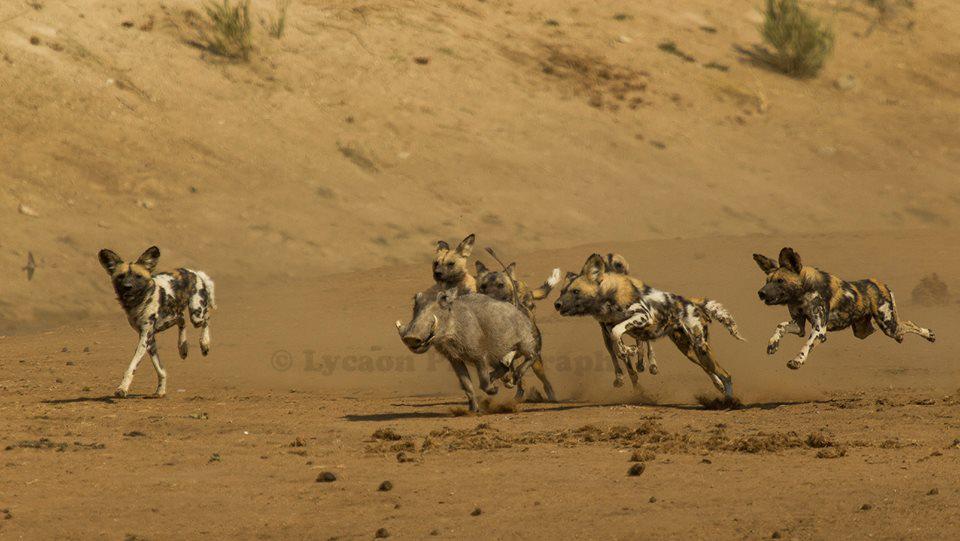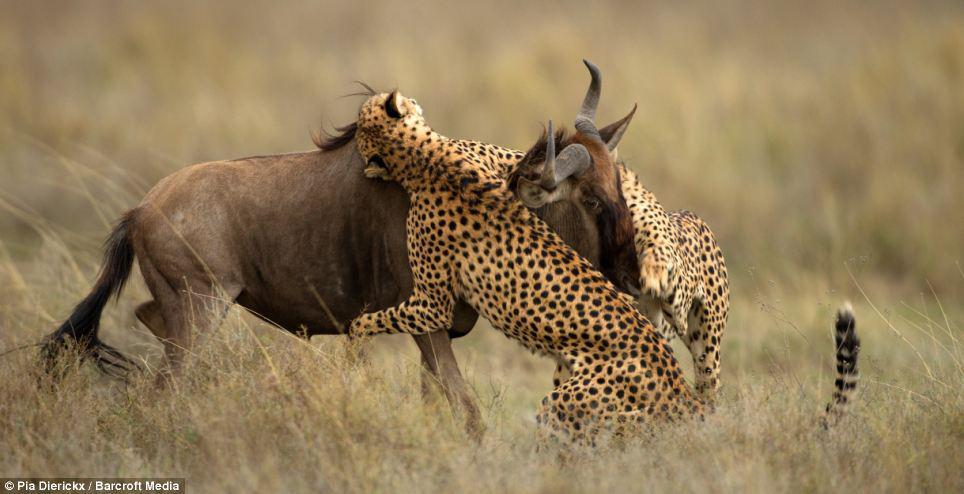The first image is the image on the left, the second image is the image on the right. For the images displayed, is the sentence "An image shows a spotted wildcat standing on its hind legs, with its front paws grasping a horned animal." factually correct? Answer yes or no. Yes. The first image is the image on the left, the second image is the image on the right. Examine the images to the left and right. Is the description "a wildebeest is being held by two cheetahs" accurate? Answer yes or no. Yes. 